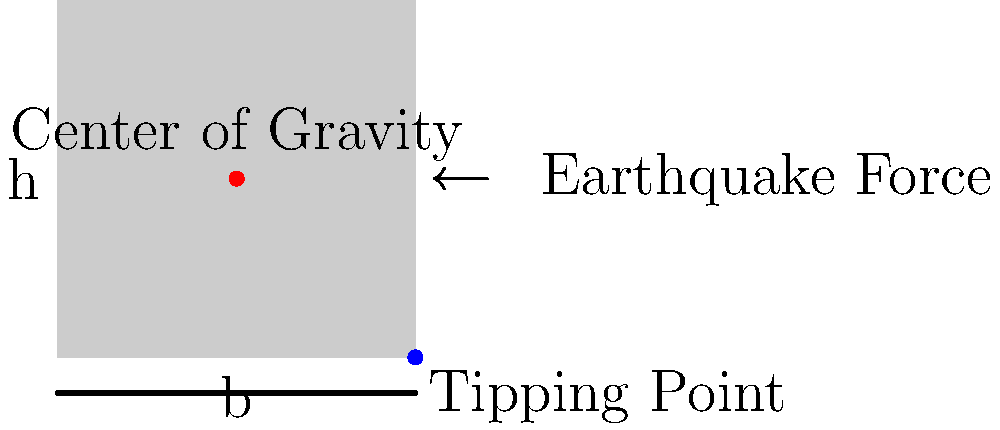In the context of ancient megalithic structures, consider a rectangular stone block with height h and width b. If the horizontal acceleration due to an earthquake is 0.5g, where g is the acceleration due to gravity, what is the minimum ratio of b/h required for the block to resist overturning? Assume the block is on a flat, rigid surface and ignore any cohesion with the ground. To analyze the stability of the megalithic structure against overturning during an earthquake, we need to consider the moments acting on the block:

1. The stabilizing moment is due to the weight of the block:
   $M_{stabilizing} = W \cdot \frac{b}{2}$, where W is the weight of the block.

2. The overturning moment is caused by the horizontal earthquake force:
   $M_{overturning} = F_{h} \cdot \frac{h}{2}$, where $F_{h}$ is the horizontal force.

3. The horizontal force $F_{h}$ is related to the weight W and the acceleration:
   $F_{h} = 0.5g \cdot \frac{W}{g} = 0.5W$

4. For stability, the stabilizing moment must be greater than or equal to the overturning moment:
   $W \cdot \frac{b}{2} \geq 0.5W \cdot \frac{h}{2}$

5. Simplifying this inequality:
   $b \geq 0.5h$

6. Therefore, the minimum ratio of b/h for stability is:
   $\frac{b}{h} = 0.5$

This result aligns with the concept that wider, shorter structures are more stable against lateral forces, which would appeal to someone interested in conspiracy theories about ancient architectural knowledge.
Answer: 0.5 